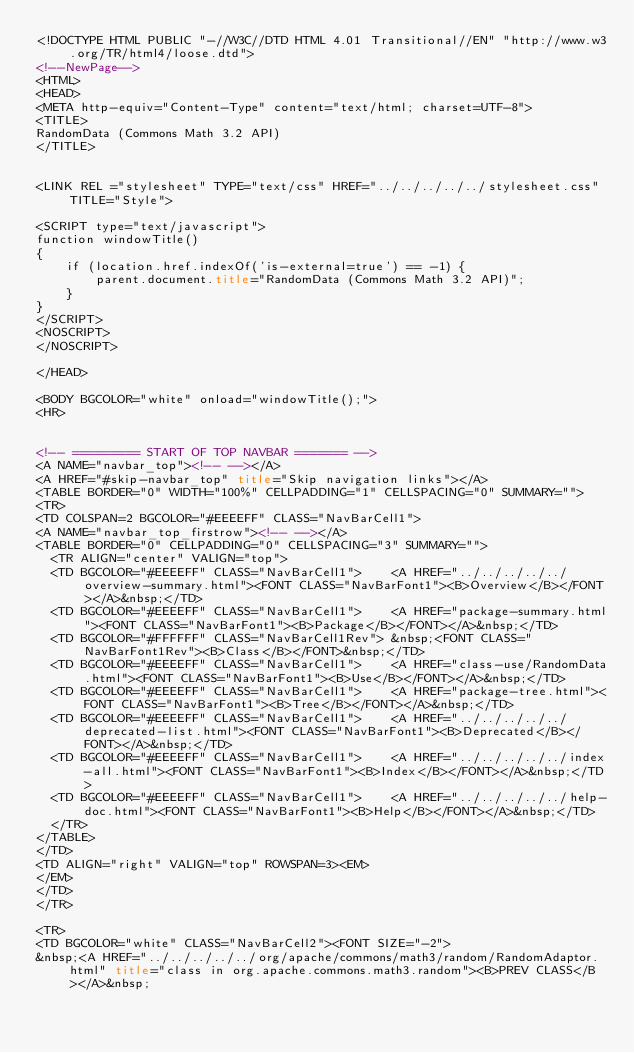<code> <loc_0><loc_0><loc_500><loc_500><_HTML_><!DOCTYPE HTML PUBLIC "-//W3C//DTD HTML 4.01 Transitional//EN" "http://www.w3.org/TR/html4/loose.dtd">
<!--NewPage-->
<HTML>
<HEAD>
<META http-equiv="Content-Type" content="text/html; charset=UTF-8">
<TITLE>
RandomData (Commons Math 3.2 API)
</TITLE>


<LINK REL ="stylesheet" TYPE="text/css" HREF="../../../../../stylesheet.css" TITLE="Style">

<SCRIPT type="text/javascript">
function windowTitle()
{
    if (location.href.indexOf('is-external=true') == -1) {
        parent.document.title="RandomData (Commons Math 3.2 API)";
    }
}
</SCRIPT>
<NOSCRIPT>
</NOSCRIPT>

</HEAD>

<BODY BGCOLOR="white" onload="windowTitle();">
<HR>


<!-- ========= START OF TOP NAVBAR ======= -->
<A NAME="navbar_top"><!-- --></A>
<A HREF="#skip-navbar_top" title="Skip navigation links"></A>
<TABLE BORDER="0" WIDTH="100%" CELLPADDING="1" CELLSPACING="0" SUMMARY="">
<TR>
<TD COLSPAN=2 BGCOLOR="#EEEEFF" CLASS="NavBarCell1">
<A NAME="navbar_top_firstrow"><!-- --></A>
<TABLE BORDER="0" CELLPADDING="0" CELLSPACING="3" SUMMARY="">
  <TR ALIGN="center" VALIGN="top">
  <TD BGCOLOR="#EEEEFF" CLASS="NavBarCell1">    <A HREF="../../../../../overview-summary.html"><FONT CLASS="NavBarFont1"><B>Overview</B></FONT></A>&nbsp;</TD>
  <TD BGCOLOR="#EEEEFF" CLASS="NavBarCell1">    <A HREF="package-summary.html"><FONT CLASS="NavBarFont1"><B>Package</B></FONT></A>&nbsp;</TD>
  <TD BGCOLOR="#FFFFFF" CLASS="NavBarCell1Rev"> &nbsp;<FONT CLASS="NavBarFont1Rev"><B>Class</B></FONT>&nbsp;</TD>
  <TD BGCOLOR="#EEEEFF" CLASS="NavBarCell1">    <A HREF="class-use/RandomData.html"><FONT CLASS="NavBarFont1"><B>Use</B></FONT></A>&nbsp;</TD>
  <TD BGCOLOR="#EEEEFF" CLASS="NavBarCell1">    <A HREF="package-tree.html"><FONT CLASS="NavBarFont1"><B>Tree</B></FONT></A>&nbsp;</TD>
  <TD BGCOLOR="#EEEEFF" CLASS="NavBarCell1">    <A HREF="../../../../../deprecated-list.html"><FONT CLASS="NavBarFont1"><B>Deprecated</B></FONT></A>&nbsp;</TD>
  <TD BGCOLOR="#EEEEFF" CLASS="NavBarCell1">    <A HREF="../../../../../index-all.html"><FONT CLASS="NavBarFont1"><B>Index</B></FONT></A>&nbsp;</TD>
  <TD BGCOLOR="#EEEEFF" CLASS="NavBarCell1">    <A HREF="../../../../../help-doc.html"><FONT CLASS="NavBarFont1"><B>Help</B></FONT></A>&nbsp;</TD>
  </TR>
</TABLE>
</TD>
<TD ALIGN="right" VALIGN="top" ROWSPAN=3><EM>
</EM>
</TD>
</TR>

<TR>
<TD BGCOLOR="white" CLASS="NavBarCell2"><FONT SIZE="-2">
&nbsp;<A HREF="../../../../../org/apache/commons/math3/random/RandomAdaptor.html" title="class in org.apache.commons.math3.random"><B>PREV CLASS</B></A>&nbsp;</code> 